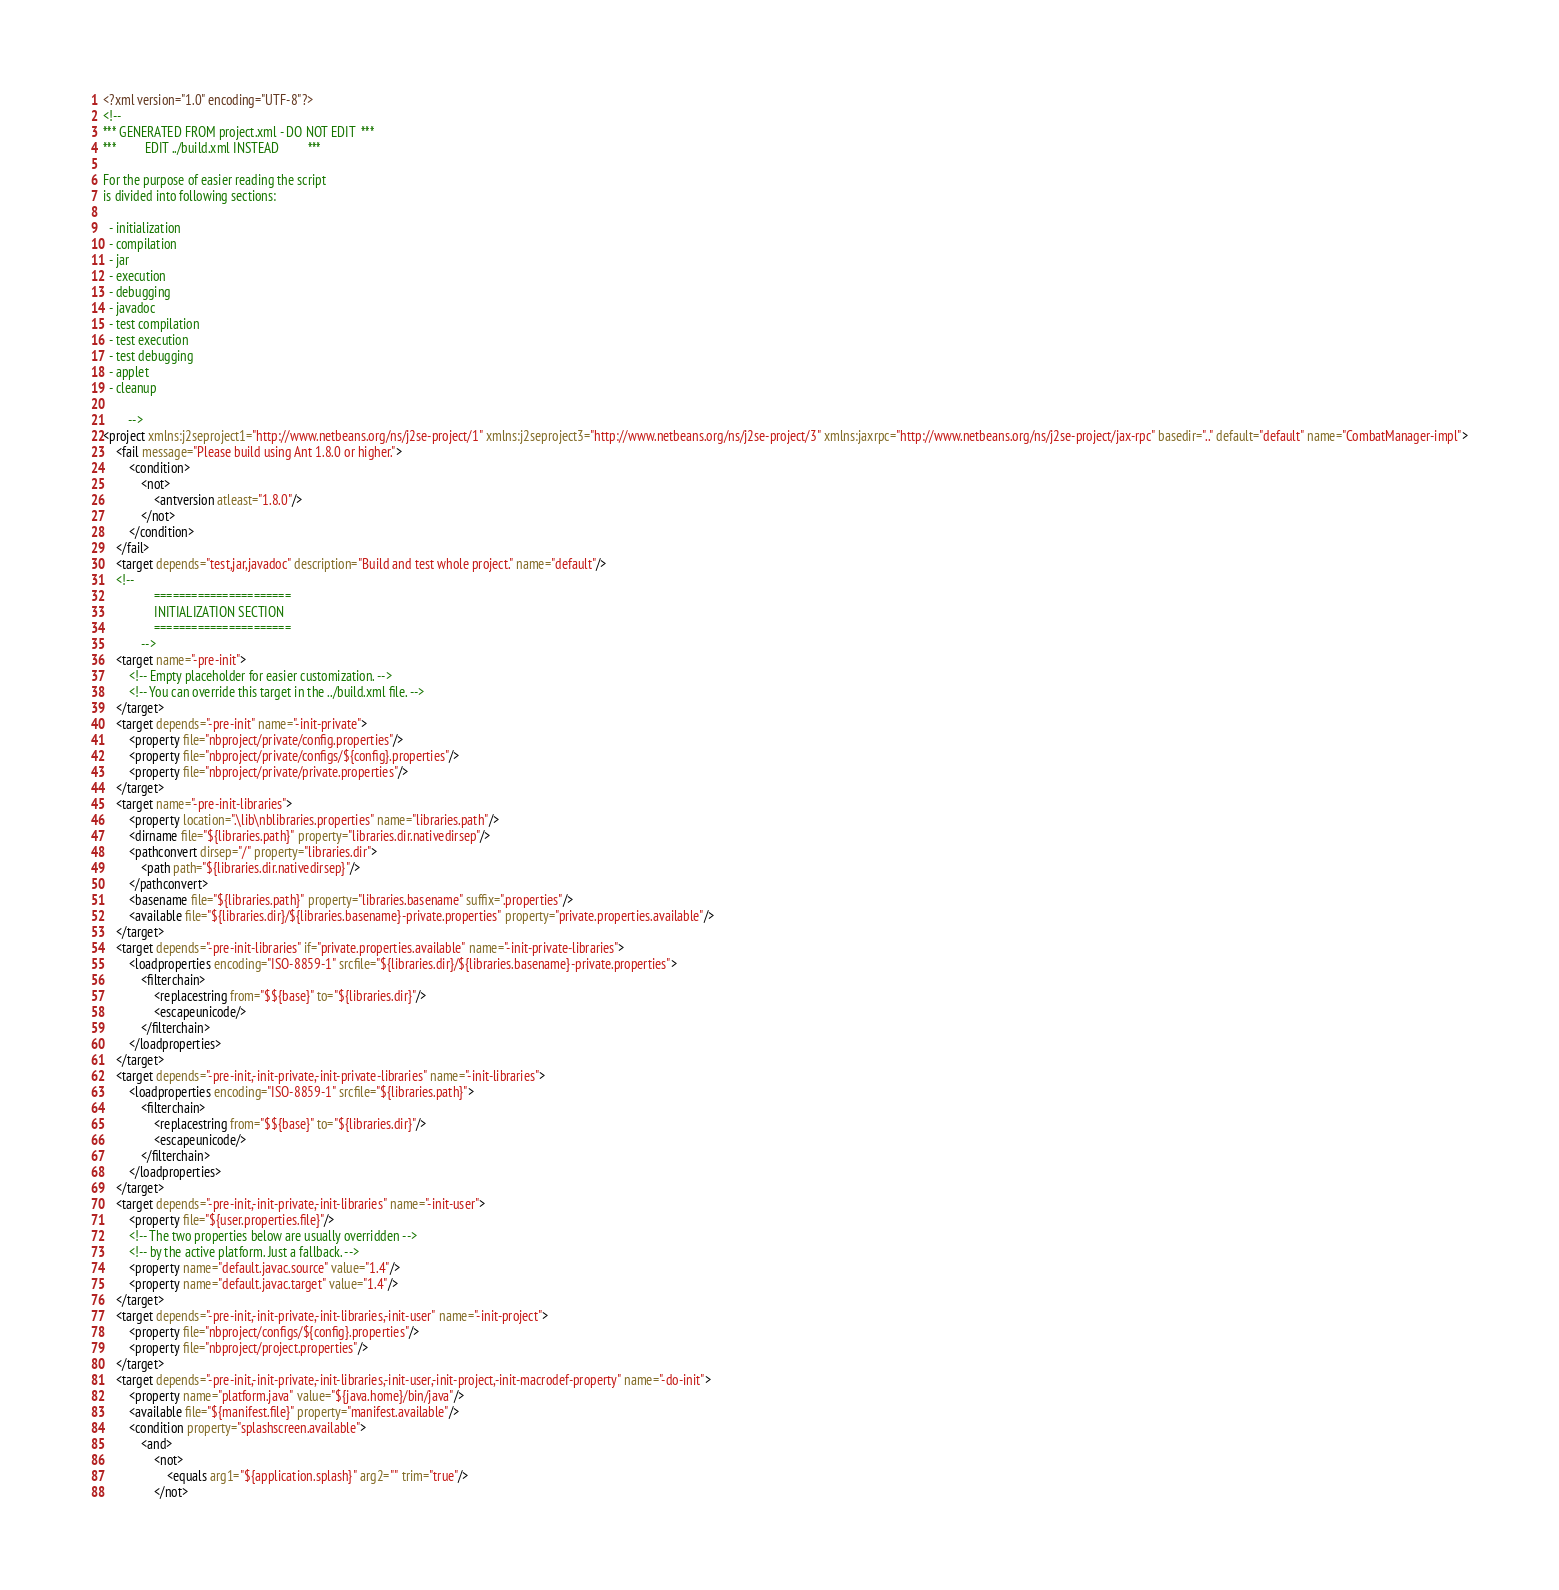<code> <loc_0><loc_0><loc_500><loc_500><_XML_><?xml version="1.0" encoding="UTF-8"?>
<!--
*** GENERATED FROM project.xml - DO NOT EDIT  ***
***         EDIT ../build.xml INSTEAD         ***

For the purpose of easier reading the script
is divided into following sections:

  - initialization
  - compilation
  - jar
  - execution
  - debugging
  - javadoc
  - test compilation
  - test execution
  - test debugging
  - applet
  - cleanup

        -->
<project xmlns:j2seproject1="http://www.netbeans.org/ns/j2se-project/1" xmlns:j2seproject3="http://www.netbeans.org/ns/j2se-project/3" xmlns:jaxrpc="http://www.netbeans.org/ns/j2se-project/jax-rpc" basedir=".." default="default" name="CombatManager-impl">
    <fail message="Please build using Ant 1.8.0 or higher.">
        <condition>
            <not>
                <antversion atleast="1.8.0"/>
            </not>
        </condition>
    </fail>
    <target depends="test,jar,javadoc" description="Build and test whole project." name="default"/>
    <!-- 
                ======================
                INITIALIZATION SECTION 
                ======================
            -->
    <target name="-pre-init">
        <!-- Empty placeholder for easier customization. -->
        <!-- You can override this target in the ../build.xml file. -->
    </target>
    <target depends="-pre-init" name="-init-private">
        <property file="nbproject/private/config.properties"/>
        <property file="nbproject/private/configs/${config}.properties"/>
        <property file="nbproject/private/private.properties"/>
    </target>
    <target name="-pre-init-libraries">
        <property location=".\lib\nblibraries.properties" name="libraries.path"/>
        <dirname file="${libraries.path}" property="libraries.dir.nativedirsep"/>
        <pathconvert dirsep="/" property="libraries.dir">
            <path path="${libraries.dir.nativedirsep}"/>
        </pathconvert>
        <basename file="${libraries.path}" property="libraries.basename" suffix=".properties"/>
        <available file="${libraries.dir}/${libraries.basename}-private.properties" property="private.properties.available"/>
    </target>
    <target depends="-pre-init-libraries" if="private.properties.available" name="-init-private-libraries">
        <loadproperties encoding="ISO-8859-1" srcfile="${libraries.dir}/${libraries.basename}-private.properties">
            <filterchain>
                <replacestring from="$${base}" to="${libraries.dir}"/>
                <escapeunicode/>
            </filterchain>
        </loadproperties>
    </target>
    <target depends="-pre-init,-init-private,-init-private-libraries" name="-init-libraries">
        <loadproperties encoding="ISO-8859-1" srcfile="${libraries.path}">
            <filterchain>
                <replacestring from="$${base}" to="${libraries.dir}"/>
                <escapeunicode/>
            </filterchain>
        </loadproperties>
    </target>
    <target depends="-pre-init,-init-private,-init-libraries" name="-init-user">
        <property file="${user.properties.file}"/>
        <!-- The two properties below are usually overridden -->
        <!-- by the active platform. Just a fallback. -->
        <property name="default.javac.source" value="1.4"/>
        <property name="default.javac.target" value="1.4"/>
    </target>
    <target depends="-pre-init,-init-private,-init-libraries,-init-user" name="-init-project">
        <property file="nbproject/configs/${config}.properties"/>
        <property file="nbproject/project.properties"/>
    </target>
    <target depends="-pre-init,-init-private,-init-libraries,-init-user,-init-project,-init-macrodef-property" name="-do-init">
        <property name="platform.java" value="${java.home}/bin/java"/>
        <available file="${manifest.file}" property="manifest.available"/>
        <condition property="splashscreen.available">
            <and>
                <not>
                    <equals arg1="${application.splash}" arg2="" trim="true"/>
                </not></code> 